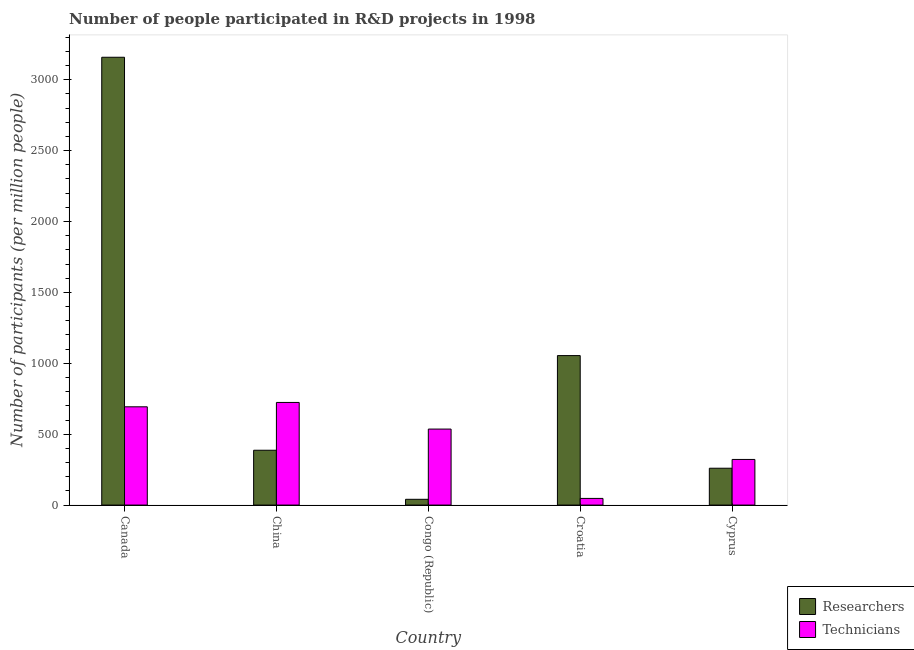How many different coloured bars are there?
Ensure brevity in your answer.  2. Are the number of bars per tick equal to the number of legend labels?
Your response must be concise. Yes. Are the number of bars on each tick of the X-axis equal?
Provide a short and direct response. Yes. How many bars are there on the 4th tick from the left?
Your response must be concise. 2. How many bars are there on the 4th tick from the right?
Offer a terse response. 2. In how many cases, is the number of bars for a given country not equal to the number of legend labels?
Your answer should be compact. 0. What is the number of researchers in Cyprus?
Ensure brevity in your answer.  259.9. Across all countries, what is the maximum number of researchers?
Offer a very short reply. 3158.52. Across all countries, what is the minimum number of technicians?
Give a very brief answer. 46.99. In which country was the number of researchers minimum?
Your response must be concise. Congo (Republic). What is the total number of researchers in the graph?
Your answer should be very brief. 4900.29. What is the difference between the number of researchers in Congo (Republic) and that in Croatia?
Offer a terse response. -1013.66. What is the difference between the number of technicians in Congo (Republic) and the number of researchers in Cyprus?
Ensure brevity in your answer.  276.16. What is the average number of technicians per country?
Make the answer very short. 464.35. What is the difference between the number of researchers and number of technicians in Canada?
Make the answer very short. 2465.42. In how many countries, is the number of researchers greater than 3000 ?
Ensure brevity in your answer.  1. What is the ratio of the number of researchers in Congo (Republic) to that in Cyprus?
Offer a terse response. 0.16. Is the difference between the number of researchers in China and Croatia greater than the difference between the number of technicians in China and Croatia?
Provide a short and direct response. No. What is the difference between the highest and the second highest number of researchers?
Provide a short and direct response. 2104.14. What is the difference between the highest and the lowest number of technicians?
Give a very brief answer. 676.83. What does the 2nd bar from the left in Canada represents?
Keep it short and to the point. Technicians. What does the 1st bar from the right in Croatia represents?
Give a very brief answer. Technicians. What is the difference between two consecutive major ticks on the Y-axis?
Make the answer very short. 500. Are the values on the major ticks of Y-axis written in scientific E-notation?
Give a very brief answer. No. Does the graph contain any zero values?
Offer a very short reply. No. Does the graph contain grids?
Ensure brevity in your answer.  No. How are the legend labels stacked?
Offer a very short reply. Vertical. What is the title of the graph?
Your answer should be compact. Number of people participated in R&D projects in 1998. What is the label or title of the X-axis?
Offer a very short reply. Country. What is the label or title of the Y-axis?
Make the answer very short. Number of participants (per million people). What is the Number of participants (per million people) of Researchers in Canada?
Provide a short and direct response. 3158.52. What is the Number of participants (per million people) of Technicians in Canada?
Your answer should be very brief. 693.1. What is the Number of participants (per million people) of Researchers in China?
Provide a short and direct response. 386.77. What is the Number of participants (per million people) in Technicians in China?
Ensure brevity in your answer.  723.82. What is the Number of participants (per million people) in Researchers in Congo (Republic)?
Provide a short and direct response. 40.72. What is the Number of participants (per million people) of Technicians in Congo (Republic)?
Give a very brief answer. 536.06. What is the Number of participants (per million people) of Researchers in Croatia?
Offer a terse response. 1054.38. What is the Number of participants (per million people) of Technicians in Croatia?
Your response must be concise. 46.99. What is the Number of participants (per million people) in Researchers in Cyprus?
Your response must be concise. 259.9. What is the Number of participants (per million people) of Technicians in Cyprus?
Offer a very short reply. 321.79. Across all countries, what is the maximum Number of participants (per million people) in Researchers?
Provide a succinct answer. 3158.52. Across all countries, what is the maximum Number of participants (per million people) of Technicians?
Provide a short and direct response. 723.82. Across all countries, what is the minimum Number of participants (per million people) in Researchers?
Offer a terse response. 40.72. Across all countries, what is the minimum Number of participants (per million people) in Technicians?
Keep it short and to the point. 46.99. What is the total Number of participants (per million people) of Researchers in the graph?
Keep it short and to the point. 4900.29. What is the total Number of participants (per million people) in Technicians in the graph?
Your answer should be very brief. 2321.75. What is the difference between the Number of participants (per million people) of Researchers in Canada and that in China?
Make the answer very short. 2771.75. What is the difference between the Number of participants (per million people) in Technicians in Canada and that in China?
Your answer should be compact. -30.72. What is the difference between the Number of participants (per million people) of Researchers in Canada and that in Congo (Republic)?
Give a very brief answer. 3117.8. What is the difference between the Number of participants (per million people) of Technicians in Canada and that in Congo (Republic)?
Your response must be concise. 157.04. What is the difference between the Number of participants (per million people) of Researchers in Canada and that in Croatia?
Offer a terse response. 2104.14. What is the difference between the Number of participants (per million people) of Technicians in Canada and that in Croatia?
Keep it short and to the point. 646.11. What is the difference between the Number of participants (per million people) in Researchers in Canada and that in Cyprus?
Your response must be concise. 2898.62. What is the difference between the Number of participants (per million people) of Technicians in Canada and that in Cyprus?
Your response must be concise. 371.31. What is the difference between the Number of participants (per million people) in Researchers in China and that in Congo (Republic)?
Your answer should be compact. 346.05. What is the difference between the Number of participants (per million people) of Technicians in China and that in Congo (Republic)?
Provide a short and direct response. 187.76. What is the difference between the Number of participants (per million people) of Researchers in China and that in Croatia?
Your answer should be very brief. -667.61. What is the difference between the Number of participants (per million people) in Technicians in China and that in Croatia?
Keep it short and to the point. 676.83. What is the difference between the Number of participants (per million people) of Researchers in China and that in Cyprus?
Your answer should be compact. 126.87. What is the difference between the Number of participants (per million people) of Technicians in China and that in Cyprus?
Ensure brevity in your answer.  402.03. What is the difference between the Number of participants (per million people) in Researchers in Congo (Republic) and that in Croatia?
Your answer should be compact. -1013.66. What is the difference between the Number of participants (per million people) of Technicians in Congo (Republic) and that in Croatia?
Your response must be concise. 489.07. What is the difference between the Number of participants (per million people) of Researchers in Congo (Republic) and that in Cyprus?
Your answer should be very brief. -219.18. What is the difference between the Number of participants (per million people) in Technicians in Congo (Republic) and that in Cyprus?
Your answer should be compact. 214.27. What is the difference between the Number of participants (per million people) in Researchers in Croatia and that in Cyprus?
Your answer should be very brief. 794.48. What is the difference between the Number of participants (per million people) in Technicians in Croatia and that in Cyprus?
Give a very brief answer. -274.79. What is the difference between the Number of participants (per million people) of Researchers in Canada and the Number of participants (per million people) of Technicians in China?
Offer a terse response. 2434.7. What is the difference between the Number of participants (per million people) in Researchers in Canada and the Number of participants (per million people) in Technicians in Congo (Republic)?
Offer a terse response. 2622.46. What is the difference between the Number of participants (per million people) in Researchers in Canada and the Number of participants (per million people) in Technicians in Croatia?
Your answer should be very brief. 3111.53. What is the difference between the Number of participants (per million people) of Researchers in Canada and the Number of participants (per million people) of Technicians in Cyprus?
Give a very brief answer. 2836.73. What is the difference between the Number of participants (per million people) in Researchers in China and the Number of participants (per million people) in Technicians in Congo (Republic)?
Provide a succinct answer. -149.29. What is the difference between the Number of participants (per million people) of Researchers in China and the Number of participants (per million people) of Technicians in Croatia?
Give a very brief answer. 339.78. What is the difference between the Number of participants (per million people) in Researchers in China and the Number of participants (per million people) in Technicians in Cyprus?
Offer a terse response. 64.99. What is the difference between the Number of participants (per million people) in Researchers in Congo (Republic) and the Number of participants (per million people) in Technicians in Croatia?
Make the answer very short. -6.27. What is the difference between the Number of participants (per million people) of Researchers in Congo (Republic) and the Number of participants (per million people) of Technicians in Cyprus?
Give a very brief answer. -281.06. What is the difference between the Number of participants (per million people) of Researchers in Croatia and the Number of participants (per million people) of Technicians in Cyprus?
Offer a very short reply. 732.59. What is the average Number of participants (per million people) of Researchers per country?
Your answer should be very brief. 980.06. What is the average Number of participants (per million people) of Technicians per country?
Your answer should be compact. 464.35. What is the difference between the Number of participants (per million people) of Researchers and Number of participants (per million people) of Technicians in Canada?
Your answer should be very brief. 2465.42. What is the difference between the Number of participants (per million people) in Researchers and Number of participants (per million people) in Technicians in China?
Ensure brevity in your answer.  -337.05. What is the difference between the Number of participants (per million people) of Researchers and Number of participants (per million people) of Technicians in Congo (Republic)?
Provide a succinct answer. -495.34. What is the difference between the Number of participants (per million people) of Researchers and Number of participants (per million people) of Technicians in Croatia?
Offer a terse response. 1007.39. What is the difference between the Number of participants (per million people) in Researchers and Number of participants (per million people) in Technicians in Cyprus?
Provide a short and direct response. -61.89. What is the ratio of the Number of participants (per million people) of Researchers in Canada to that in China?
Keep it short and to the point. 8.17. What is the ratio of the Number of participants (per million people) in Technicians in Canada to that in China?
Make the answer very short. 0.96. What is the ratio of the Number of participants (per million people) of Researchers in Canada to that in Congo (Republic)?
Your response must be concise. 77.56. What is the ratio of the Number of participants (per million people) in Technicians in Canada to that in Congo (Republic)?
Provide a succinct answer. 1.29. What is the ratio of the Number of participants (per million people) in Researchers in Canada to that in Croatia?
Ensure brevity in your answer.  3. What is the ratio of the Number of participants (per million people) in Technicians in Canada to that in Croatia?
Ensure brevity in your answer.  14.75. What is the ratio of the Number of participants (per million people) of Researchers in Canada to that in Cyprus?
Ensure brevity in your answer.  12.15. What is the ratio of the Number of participants (per million people) of Technicians in Canada to that in Cyprus?
Keep it short and to the point. 2.15. What is the ratio of the Number of participants (per million people) of Researchers in China to that in Congo (Republic)?
Make the answer very short. 9.5. What is the ratio of the Number of participants (per million people) of Technicians in China to that in Congo (Republic)?
Offer a very short reply. 1.35. What is the ratio of the Number of participants (per million people) in Researchers in China to that in Croatia?
Your answer should be compact. 0.37. What is the ratio of the Number of participants (per million people) of Technicians in China to that in Croatia?
Provide a succinct answer. 15.4. What is the ratio of the Number of participants (per million people) in Researchers in China to that in Cyprus?
Offer a very short reply. 1.49. What is the ratio of the Number of participants (per million people) in Technicians in China to that in Cyprus?
Your answer should be very brief. 2.25. What is the ratio of the Number of participants (per million people) in Researchers in Congo (Republic) to that in Croatia?
Provide a short and direct response. 0.04. What is the ratio of the Number of participants (per million people) in Technicians in Congo (Republic) to that in Croatia?
Give a very brief answer. 11.41. What is the ratio of the Number of participants (per million people) in Researchers in Congo (Republic) to that in Cyprus?
Your answer should be very brief. 0.16. What is the ratio of the Number of participants (per million people) of Technicians in Congo (Republic) to that in Cyprus?
Provide a short and direct response. 1.67. What is the ratio of the Number of participants (per million people) of Researchers in Croatia to that in Cyprus?
Your response must be concise. 4.06. What is the ratio of the Number of participants (per million people) in Technicians in Croatia to that in Cyprus?
Ensure brevity in your answer.  0.15. What is the difference between the highest and the second highest Number of participants (per million people) in Researchers?
Ensure brevity in your answer.  2104.14. What is the difference between the highest and the second highest Number of participants (per million people) of Technicians?
Your response must be concise. 30.72. What is the difference between the highest and the lowest Number of participants (per million people) of Researchers?
Your answer should be very brief. 3117.8. What is the difference between the highest and the lowest Number of participants (per million people) of Technicians?
Make the answer very short. 676.83. 